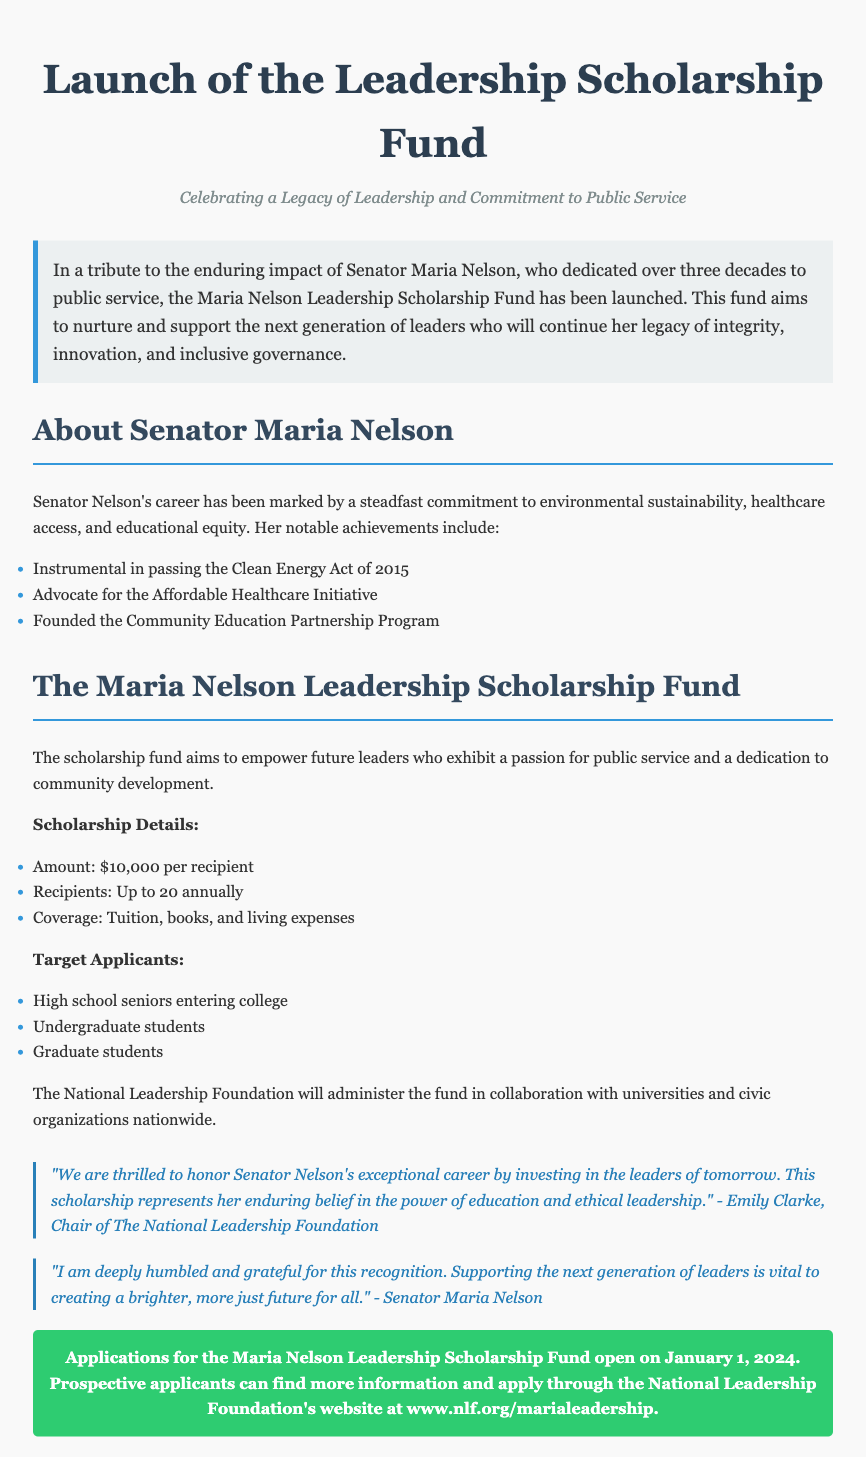what is the name of the scholarship fund? The document introduces the scholarly fund named after Senator Maria Nelson as the Maria Nelson Leadership Scholarship Fund.
Answer: Maria Nelson Leadership Scholarship Fund who is the retired politician honored by this scholarship? The retired politician being honored by the scholarship is Senator Maria Nelson, who dedicated over three decades to public service.
Answer: Senator Maria Nelson what is the scholarship amount per recipient? The scholarship amount for each recipient is specified in the document.
Answer: $10,000 how many recipients will be selected annually? The document states the number of recipients awarded annually.
Answer: Up to 20 when do applications for the scholarship open? The document provides the date when applications for the scholarship begin.
Answer: January 1, 2024 who administers the Maria Nelson Leadership Scholarship Fund? The document mentions the organization responsible for administering the fund.
Answer: National Leadership Foundation what are the eligibility levels for scholarship applicants? The document lists the different educational levels of eligible applicants.
Answer: High school seniors, undergraduate, graduate students what was a notable achievement of Senator Nelson related to healthcare? The document contains a specific mention of Senator Nelson's advocacy in healthcare.
Answer: Affordable Healthcare Initiative what is the main goal of the Maria Nelson Leadership Scholarship Fund? The document outlines the fund's primary aim regarding leadership development.
Answer: Empower future leaders 